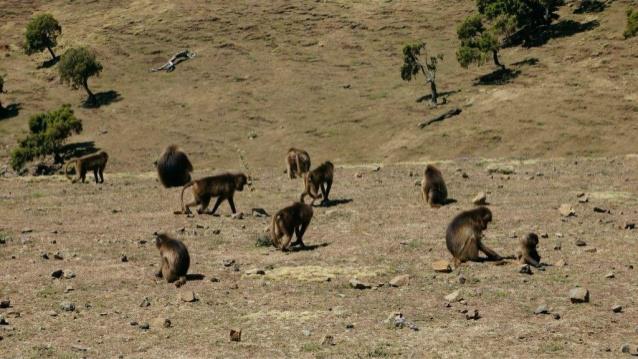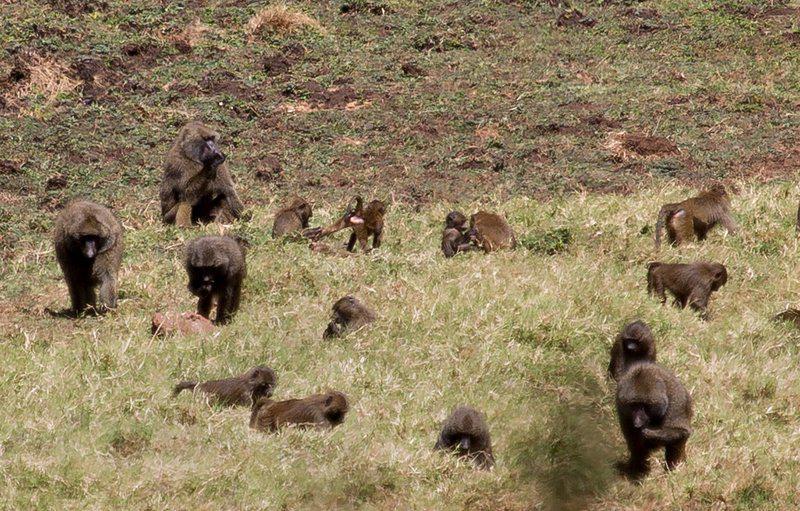The first image is the image on the left, the second image is the image on the right. Assess this claim about the two images: "The left image contains no more than four baboons and does not contain any baby baboons.". Correct or not? Answer yes or no. No. The first image is the image on the left, the second image is the image on the right. Evaluate the accuracy of this statement regarding the images: "There are seven lesser apes in the image to the right.". Is it true? Answer yes or no. No. 